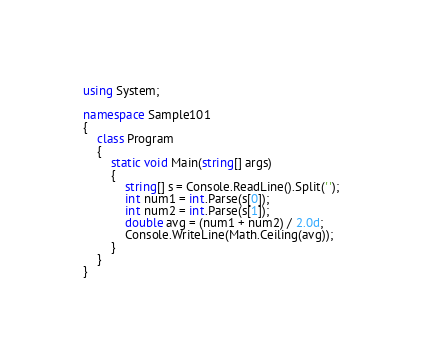Convert code to text. <code><loc_0><loc_0><loc_500><loc_500><_C#_>using System;

namespace Sample101
{
    class Program
    {
        static void Main(string[] args)
        {
            string[] s = Console.ReadLine().Split(' ');
            int num1 = int.Parse(s[0]);
            int num2 = int.Parse(s[1]);
            double avg = (num1 + num2) / 2.0d;
            Console.WriteLine(Math.Ceiling(avg));
        }
    }
}</code> 